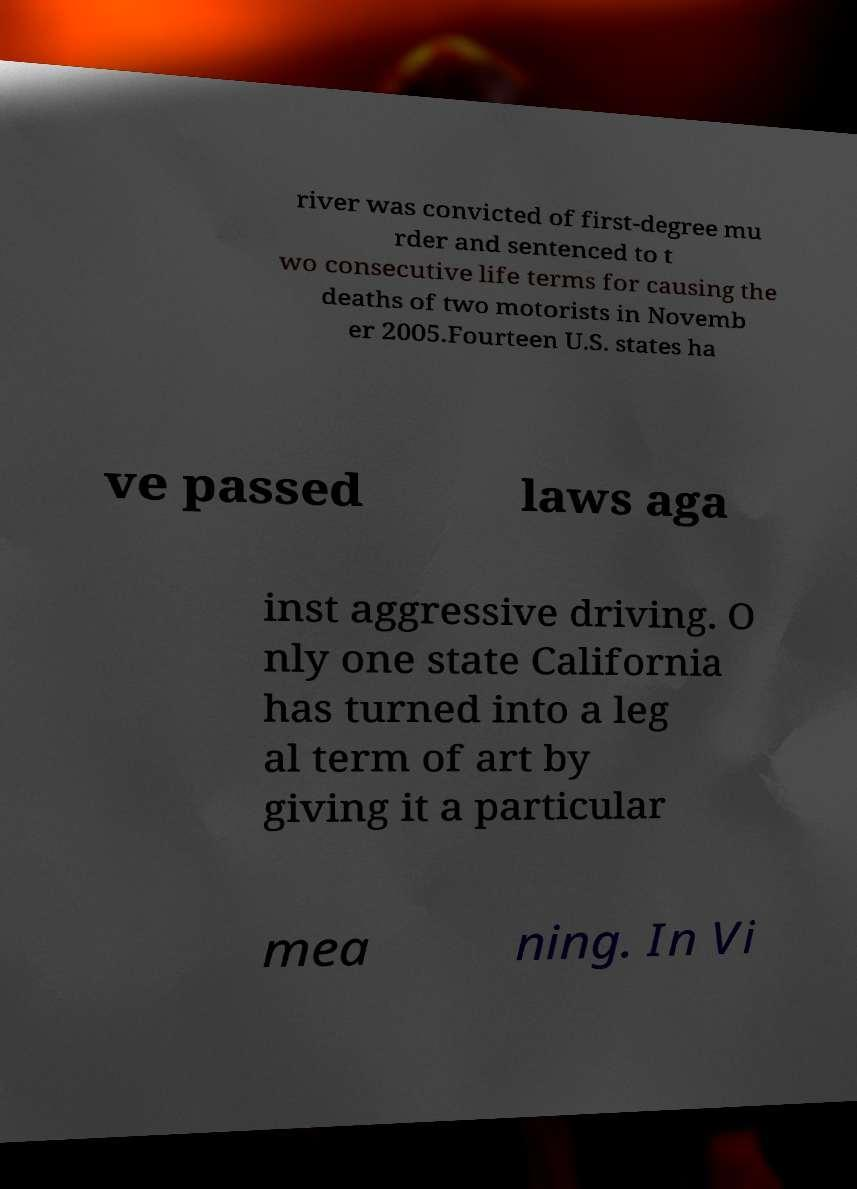Could you assist in decoding the text presented in this image and type it out clearly? river was convicted of first-degree mu rder and sentenced to t wo consecutive life terms for causing the deaths of two motorists in Novemb er 2005.Fourteen U.S. states ha ve passed laws aga inst aggressive driving. O nly one state California has turned into a leg al term of art by giving it a particular mea ning. In Vi 